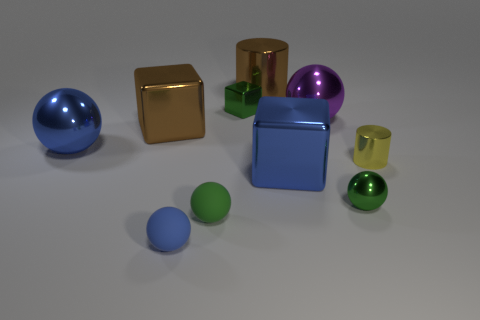What size is the rubber object that is the same color as the small shiny cube?
Keep it short and to the point. Small. What number of purple objects are either metal objects or big things?
Keep it short and to the point. 1. What number of other objects are there of the same shape as the big purple thing?
Your answer should be very brief. 4. What shape is the thing that is to the left of the green rubber sphere and in front of the tiny cylinder?
Make the answer very short. Sphere. There is a brown metallic cylinder; are there any tiny green spheres left of it?
Offer a very short reply. Yes. There is a green shiny object that is the same shape as the purple object; what size is it?
Offer a terse response. Small. Are there any other things that have the same size as the yellow cylinder?
Offer a terse response. Yes. Is the shape of the blue matte thing the same as the small green rubber thing?
Provide a short and direct response. Yes. What size is the green object that is behind the blue shiny thing that is to the right of the blue shiny sphere?
Give a very brief answer. Small. What is the color of the other metallic thing that is the same shape as the yellow metallic object?
Ensure brevity in your answer.  Brown. 